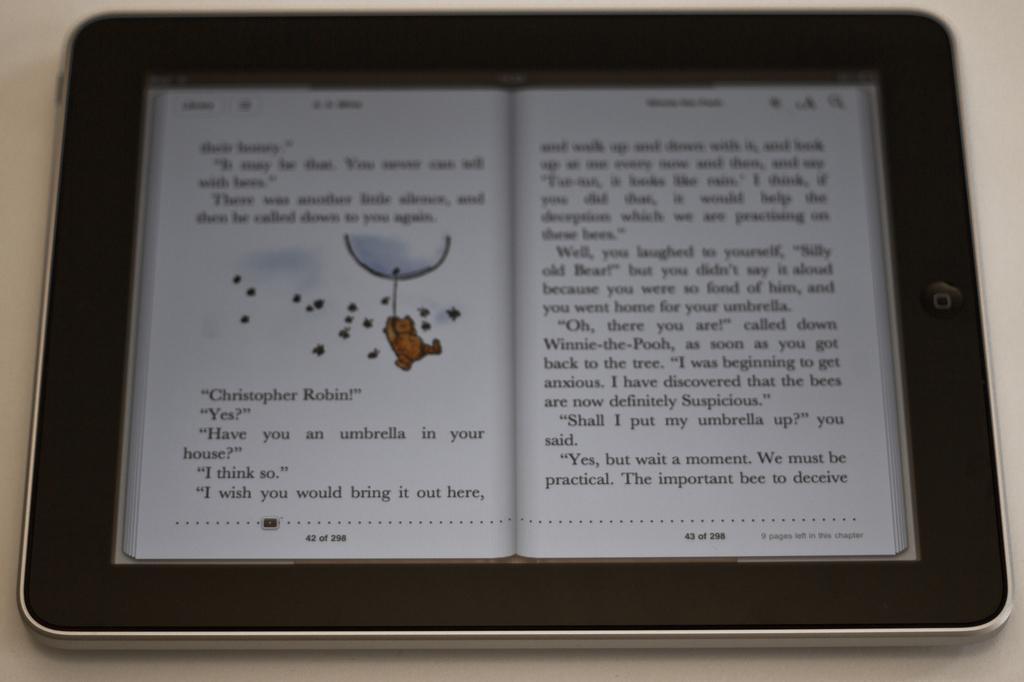<image>
Describe the image concisely. A children's book on an iPad at page 42 of 298 about Christopher Robin. 